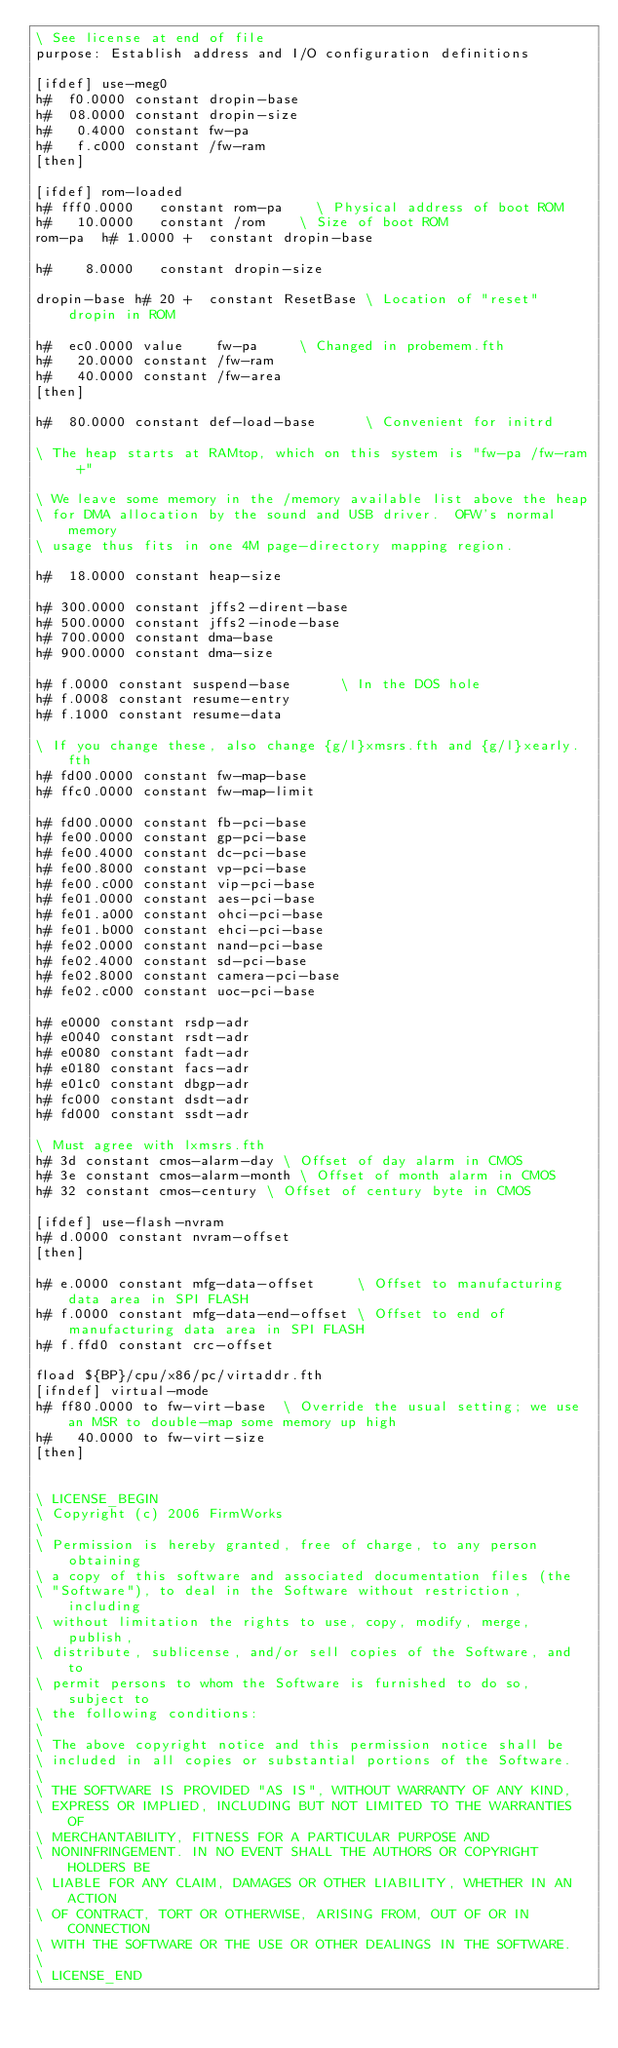<code> <loc_0><loc_0><loc_500><loc_500><_Forth_>\ See license at end of file
purpose: Establish address and I/O configuration definitions

[ifdef] use-meg0
h#  f0.0000 constant dropin-base
h#  08.0000 constant dropin-size
h#   0.4000 constant fw-pa
h#   f.c000 constant /fw-ram
[then]

[ifdef] rom-loaded
h# fff0.0000   constant rom-pa		\ Physical address of boot ROM
h#   10.0000   constant /rom		\ Size of boot ROM
rom-pa  h# 1.0000 +  constant dropin-base

h#    8.0000   constant dropin-size

dropin-base h# 20 +  constant ResetBase	\ Location of "reset" dropin in ROM

h#  ec0.0000 value    fw-pa     \ Changed in probemem.fth
h#   20.0000 constant /fw-ram
h#   40.0000 constant /fw-area
[then]

h#  80.0000 constant def-load-base      \ Convenient for initrd

\ The heap starts at RAMtop, which on this system is "fw-pa /fw-ram +"

\ We leave some memory in the /memory available list above the heap
\ for DMA allocation by the sound and USB driver.  OFW's normal memory
\ usage thus fits in one 4M page-directory mapping region.

h#  18.0000 constant heap-size

h# 300.0000 constant jffs2-dirent-base
h# 500.0000 constant jffs2-inode-base
h# 700.0000 constant dma-base
h# 900.0000 constant dma-size

h# f.0000 constant suspend-base      \ In the DOS hole
h# f.0008 constant resume-entry
h# f.1000 constant resume-data

\ If you change these, also change {g/l}xmsrs.fth and {g/l}xearly.fth
h# fd00.0000 constant fw-map-base
h# ffc0.0000 constant fw-map-limit

h# fd00.0000 constant fb-pci-base
h# fe00.0000 constant gp-pci-base
h# fe00.4000 constant dc-pci-base
h# fe00.8000 constant vp-pci-base
h# fe00.c000 constant vip-pci-base
h# fe01.0000 constant aes-pci-base
h# fe01.a000 constant ohci-pci-base
h# fe01.b000 constant ehci-pci-base
h# fe02.0000 constant nand-pci-base
h# fe02.4000 constant sd-pci-base
h# fe02.8000 constant camera-pci-base
h# fe02.c000 constant uoc-pci-base

h# e0000 constant rsdp-adr
h# e0040 constant rsdt-adr
h# e0080 constant fadt-adr
h# e0180 constant facs-adr
h# e01c0 constant dbgp-adr
h# fc000 constant dsdt-adr
h# fd000 constant ssdt-adr

\ Must agree with lxmsrs.fth
h# 3d constant cmos-alarm-day	\ Offset of day alarm in CMOS
h# 3e constant cmos-alarm-month	\ Offset of month alarm in CMOS
h# 32 constant cmos-century	\ Offset of century byte in CMOS

[ifdef] use-flash-nvram
h# d.0000 constant nvram-offset
[then]

h# e.0000 constant mfg-data-offset     \ Offset to manufacturing data area in SPI FLASH
h# f.0000 constant mfg-data-end-offset \ Offset to end of manufacturing data area in SPI FLASH
h# f.ffd0 constant crc-offset

fload ${BP}/cpu/x86/pc/virtaddr.fth
[ifndef] virtual-mode
h# ff80.0000 to fw-virt-base  \ Override the usual setting; we use an MSR to double-map some memory up high
h#   40.0000 to fw-virt-size
[then]


\ LICENSE_BEGIN
\ Copyright (c) 2006 FirmWorks
\ 
\ Permission is hereby granted, free of charge, to any person obtaining
\ a copy of this software and associated documentation files (the
\ "Software"), to deal in the Software without restriction, including
\ without limitation the rights to use, copy, modify, merge, publish,
\ distribute, sublicense, and/or sell copies of the Software, and to
\ permit persons to whom the Software is furnished to do so, subject to
\ the following conditions:
\ 
\ The above copyright notice and this permission notice shall be
\ included in all copies or substantial portions of the Software.
\ 
\ THE SOFTWARE IS PROVIDED "AS IS", WITHOUT WARRANTY OF ANY KIND,
\ EXPRESS OR IMPLIED, INCLUDING BUT NOT LIMITED TO THE WARRANTIES OF
\ MERCHANTABILITY, FITNESS FOR A PARTICULAR PURPOSE AND
\ NONINFRINGEMENT. IN NO EVENT SHALL THE AUTHORS OR COPYRIGHT HOLDERS BE
\ LIABLE FOR ANY CLAIM, DAMAGES OR OTHER LIABILITY, WHETHER IN AN ACTION
\ OF CONTRACT, TORT OR OTHERWISE, ARISING FROM, OUT OF OR IN CONNECTION
\ WITH THE SOFTWARE OR THE USE OR OTHER DEALINGS IN THE SOFTWARE.
\
\ LICENSE_END
</code> 